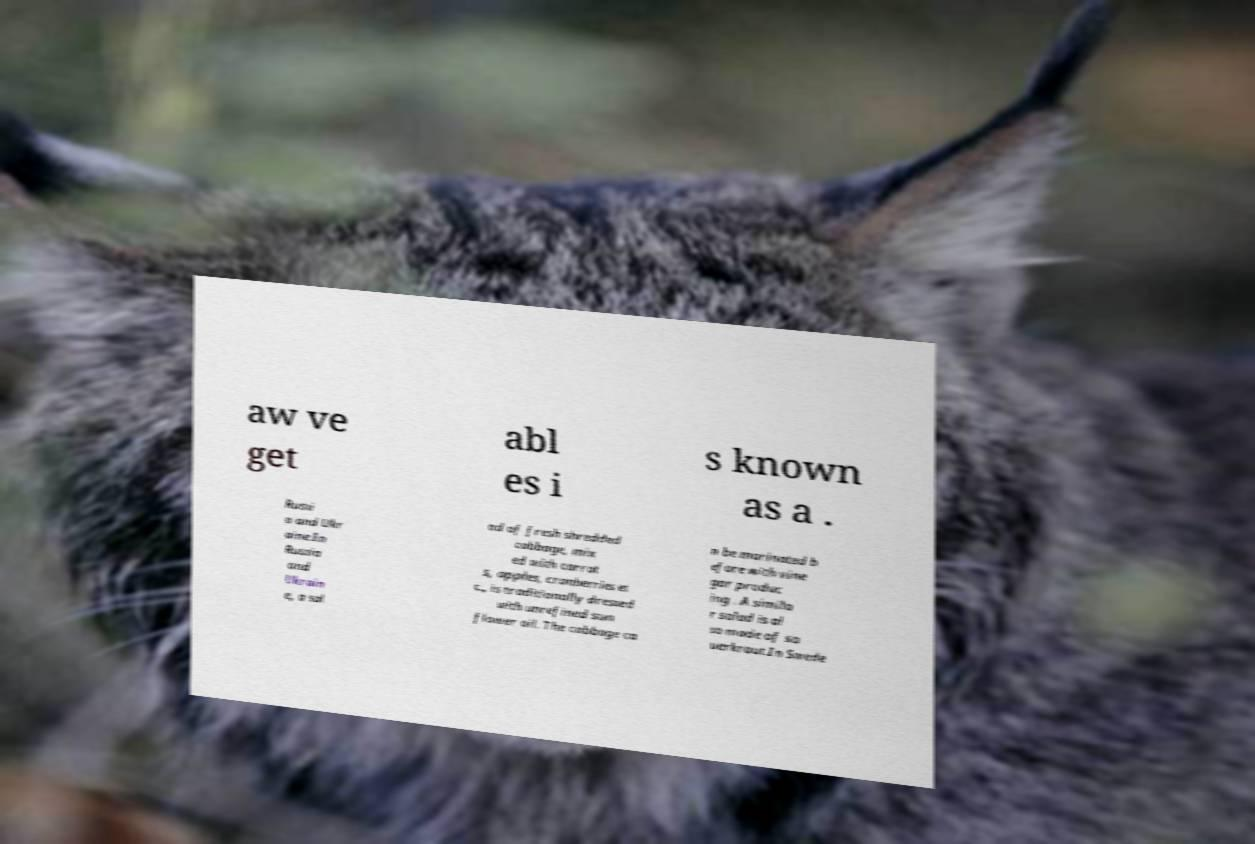Could you extract and type out the text from this image? aw ve get abl es i s known as a . Russi a and Ukr aine.In Russia and Ukrain e, a sal ad of fresh shredded cabbage, mix ed with carrot s, apples, cranberries et c., is traditionally dressed with unrefined sun flower oil. The cabbage ca n be marinated b efore with vine gar produc ing . A simila r salad is al so made of sa uerkraut.In Swede 